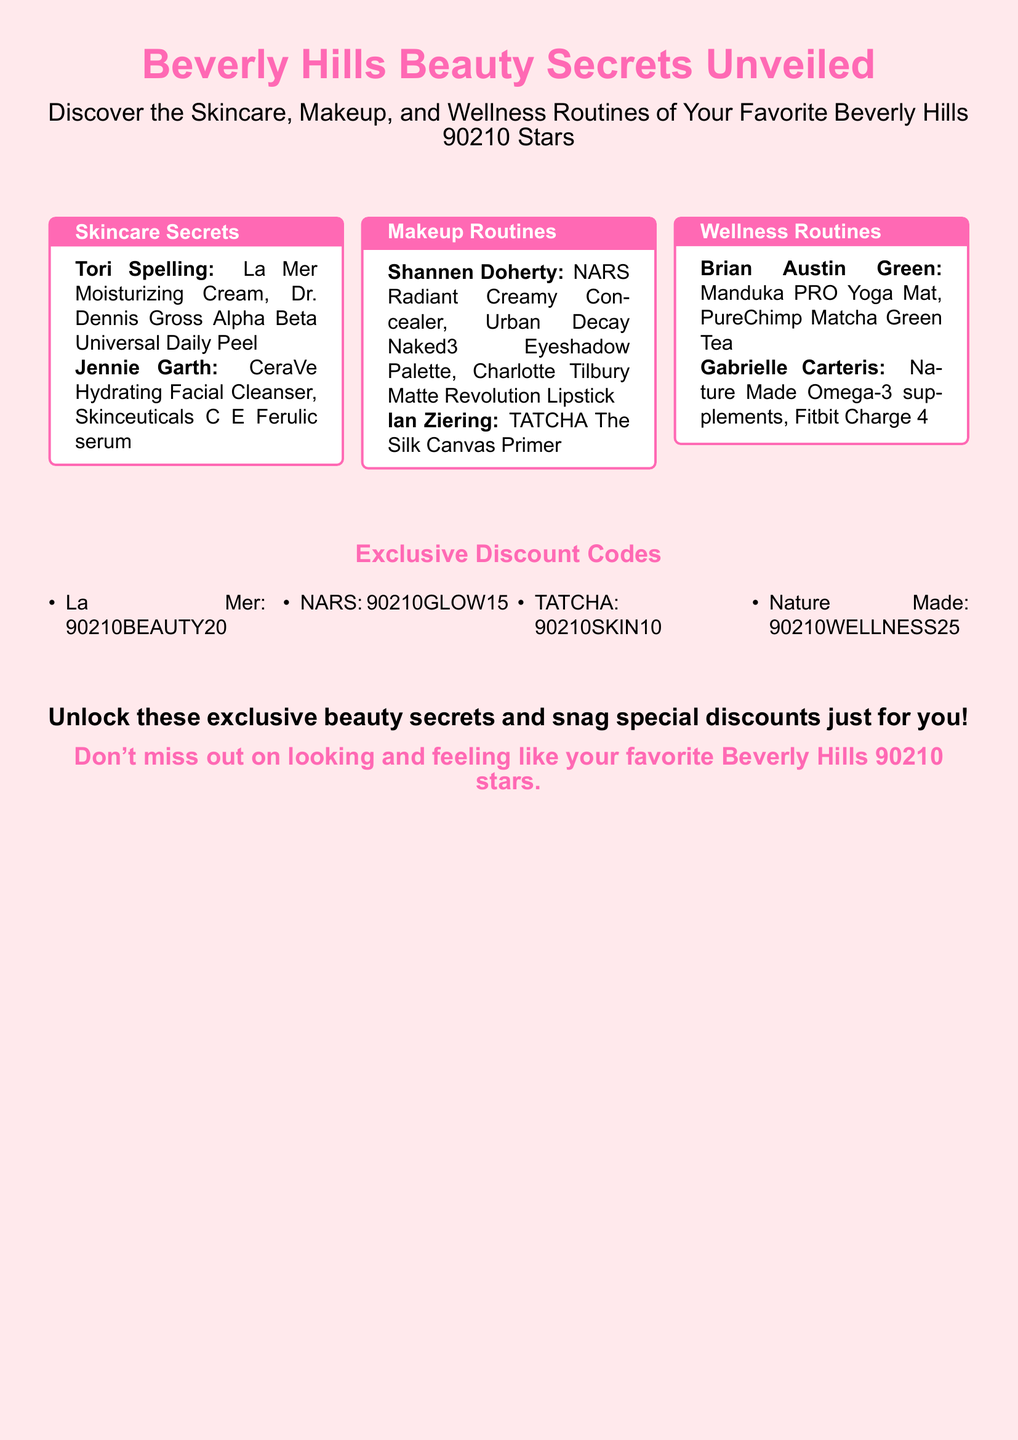What skincare product does Tori Spelling use? The document lists Tori Spelling's skincare products in the skincare section, including La Mer Moisturizing Cream.
Answer: La Mer Moisturizing Cream Which celebrities recommend the NARS makeup products? The document specifies that Shannen Doherty uses NARS Radiant Creamy Concealer in the makeup routines.
Answer: Shannen Doherty What wellness product is associated with Brian Austin Green? The wellness section shows that Brian Austin Green uses a Manduka PRO Yoga Mat.
Answer: Manduka PRO Yoga Mat How many discount codes are provided? The document lists four specific discount codes under the exclusive discount codes section.
Answer: Four Which discount code corresponds to Nature Made? The document provides Nature Made's discount code in the exclusive discount codes section.
Answer: 90210WELLNESS25 What skincare routine product does Jennie Garth use? The document mentions Jennie Garth's skincare products, including CeraVe Hydrating Facial Cleanser.
Answer: CeraVe Hydrating Facial Cleanser Which makeup brand is Ian Ziering associated with? The document includes a section on makeup routines, stating that Ian Ziering uses TATCHA The Silk Canvas Primer.
Answer: TATCHA What color is the background of the advertisement? The document shows that the page color is light pink, specifically lightpink!30.
Answer: Light pink 